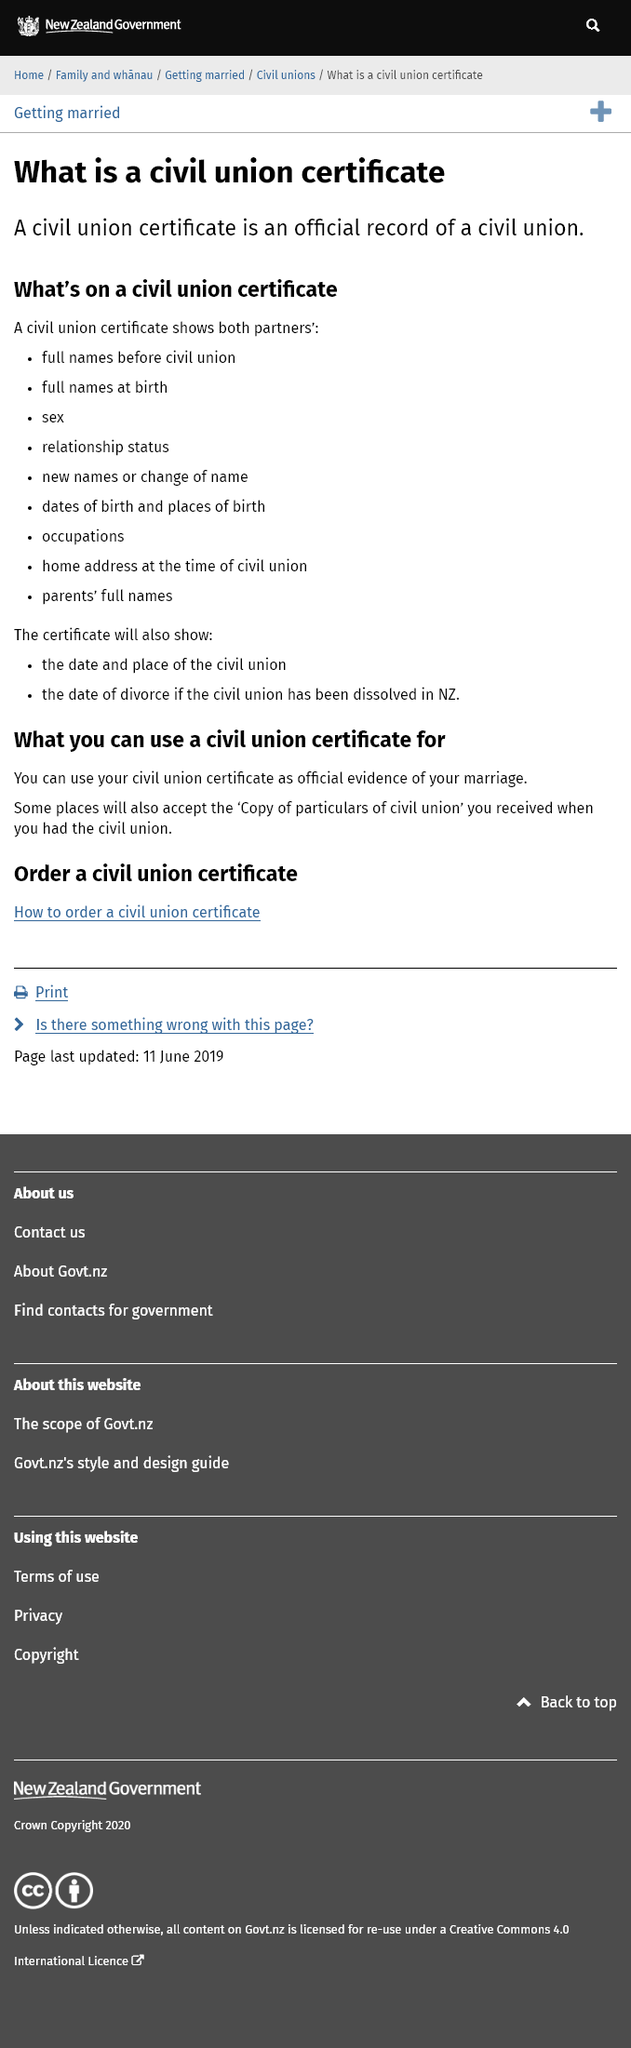Point out several critical features in this image. Sex is shown on civil union certificates, not marriages. A civil union certificate is an official record of a civil union between two people, established to acknowledge their committed relationship and provide them with legal rights and benefits. The relationship status is shown on a civil union certificate. 